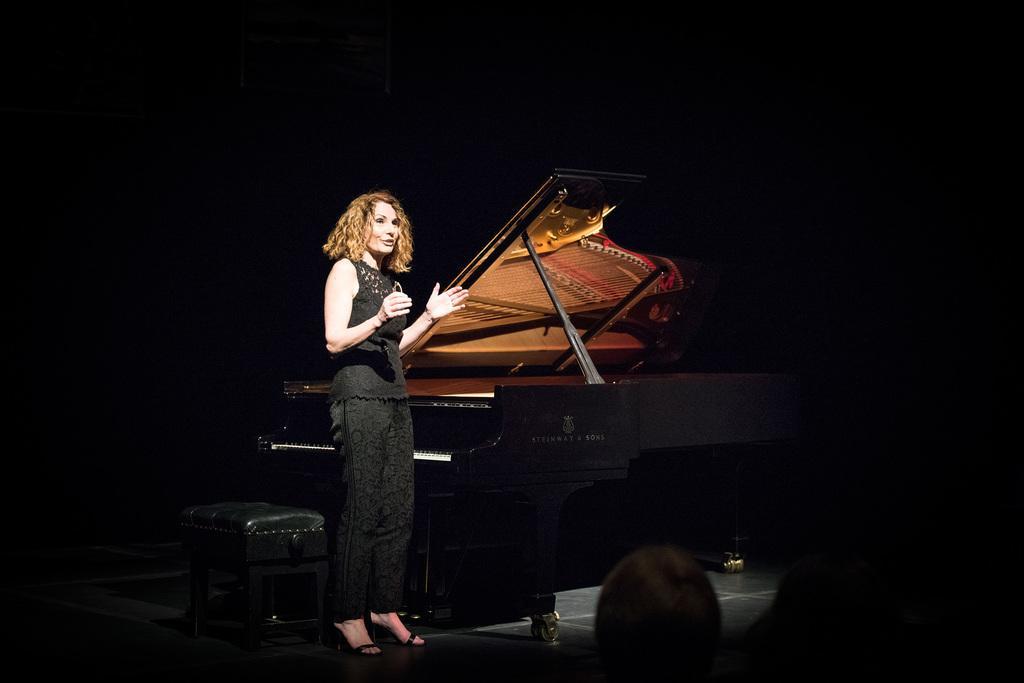Could you give a brief overview of what you see in this image? This picture shows a woman standing and speaking and we see a violin and a stool 